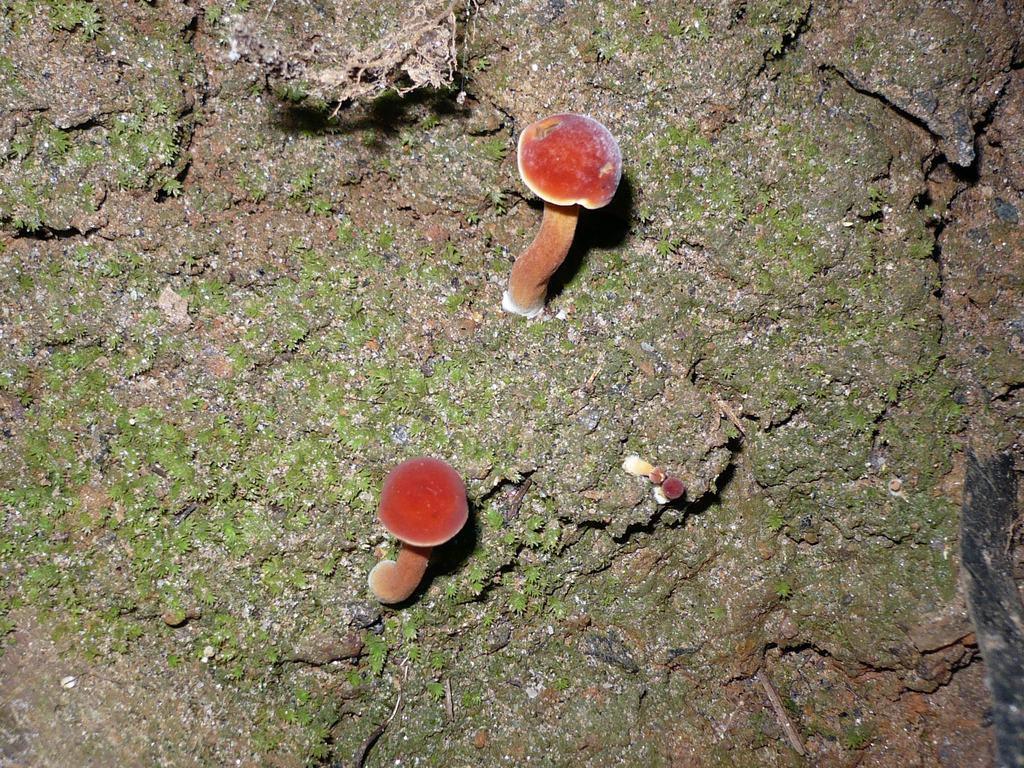Describe this image in one or two sentences. In this picture we can see few mushrooms. 